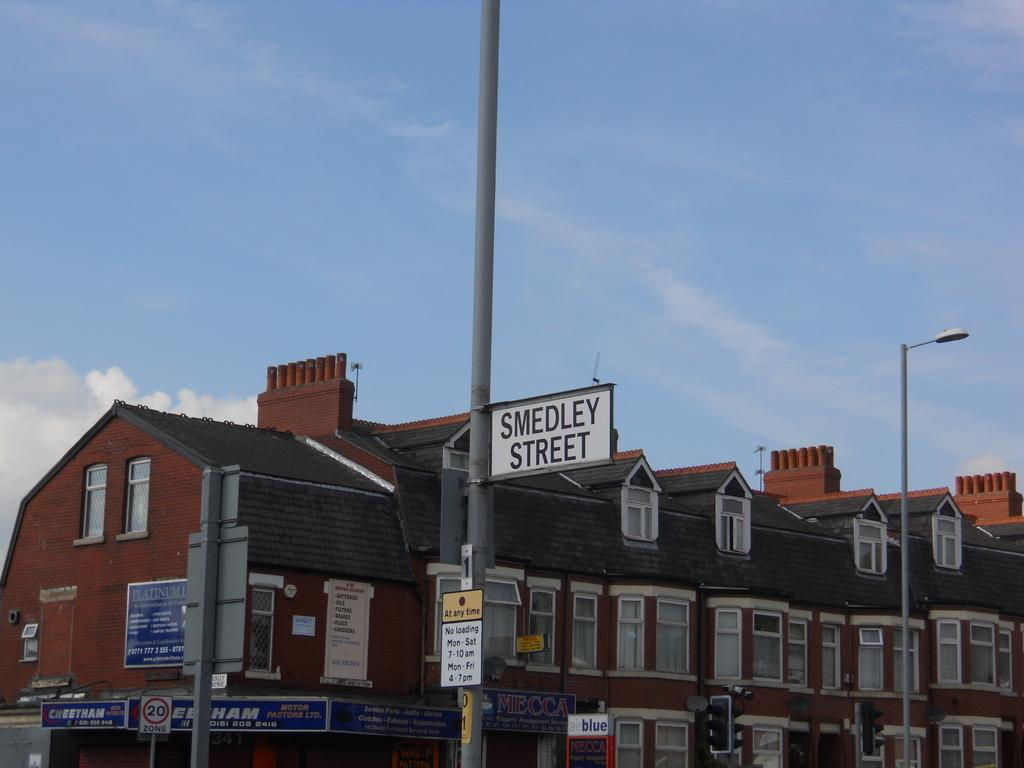What objects are on poles in the image? There are boards and lights on poles in the image. What traffic control devices are present in the image? There are traffic signals in the image. What can be seen in the background of the image? There is a building, windows, and the sky visible in the background of the image. What is the condition of the sky in the image? The sky is visible in the background of the image, and clouds are present. Can you tell me how many people are using the lift in the image? There is no lift present in the image; it features boards, lights, traffic signals, a building, windows, and the sky. What type of breath is visible coming from the tank in the image? There is no tank present in the image, and therefore no breath can be observed. 